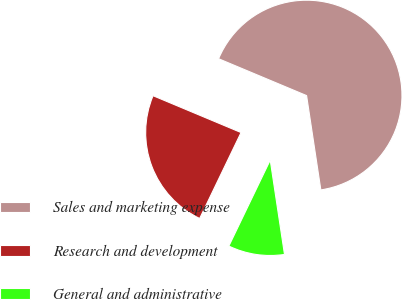Convert chart. <chart><loc_0><loc_0><loc_500><loc_500><pie_chart><fcel>Sales and marketing expense<fcel>Research and development<fcel>General and administrative<nl><fcel>66.3%<fcel>24.17%<fcel>9.53%<nl></chart> 